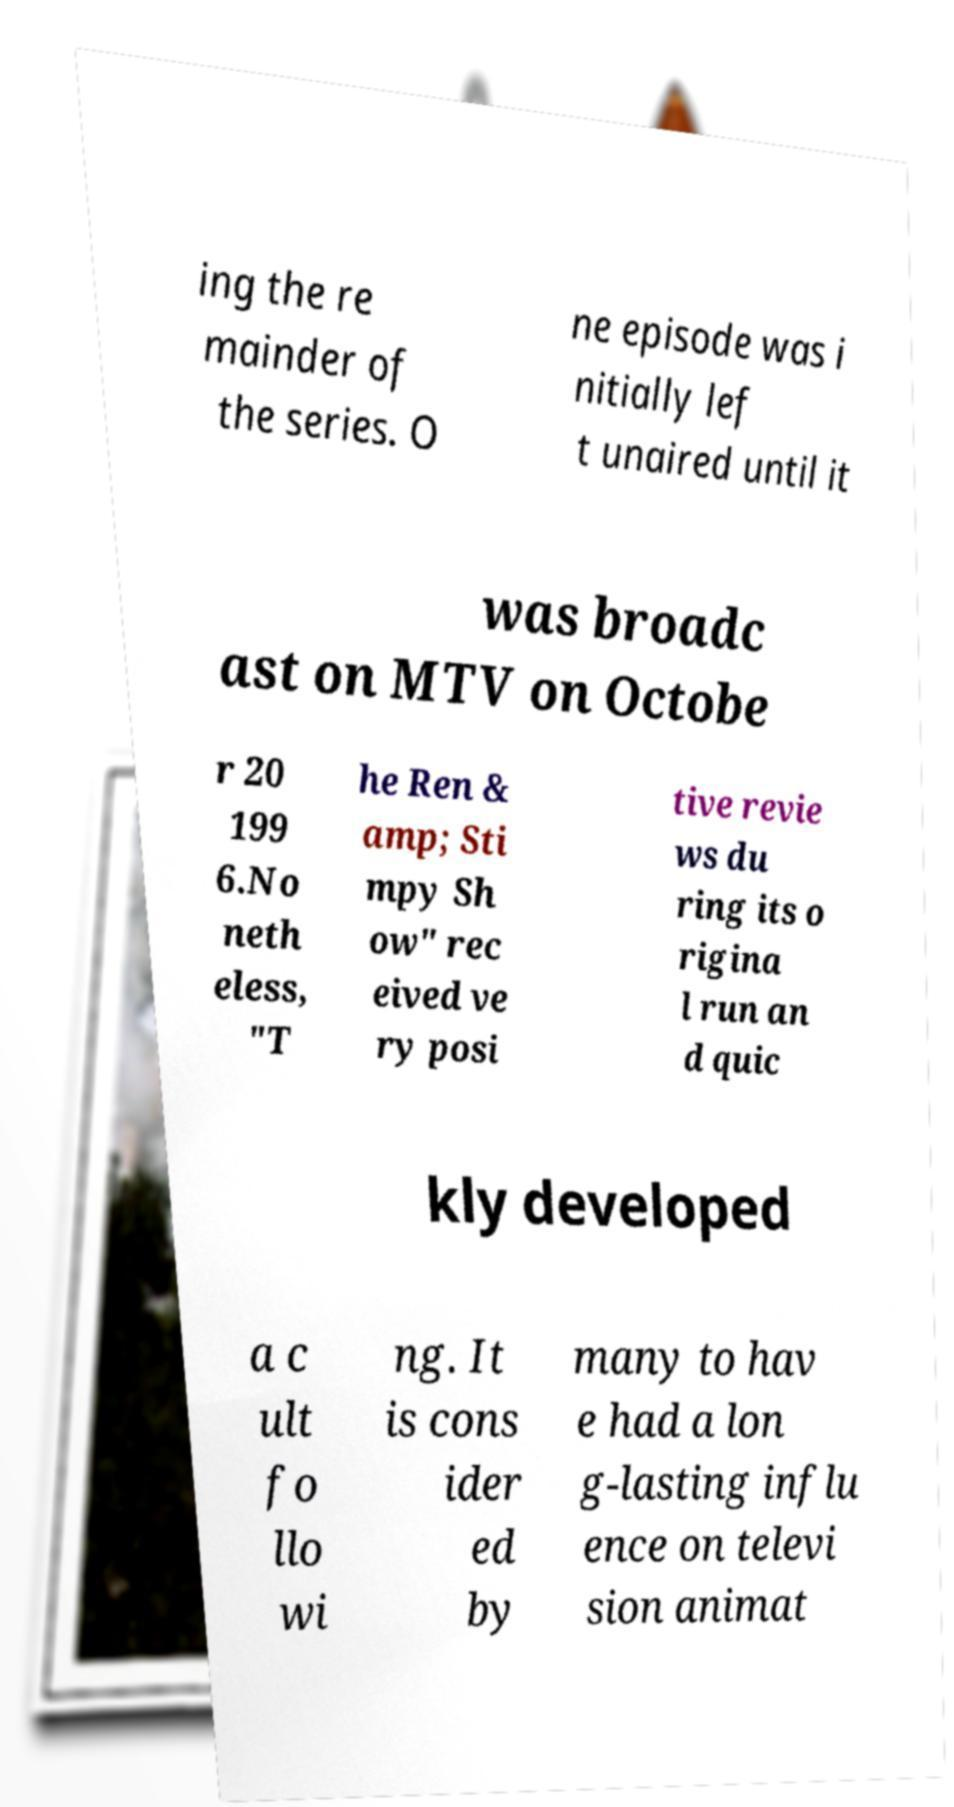For documentation purposes, I need the text within this image transcribed. Could you provide that? ing the re mainder of the series. O ne episode was i nitially lef t unaired until it was broadc ast on MTV on Octobe r 20 199 6.No neth eless, "T he Ren & amp; Sti mpy Sh ow" rec eived ve ry posi tive revie ws du ring its o rigina l run an d quic kly developed a c ult fo llo wi ng. It is cons ider ed by many to hav e had a lon g-lasting influ ence on televi sion animat 